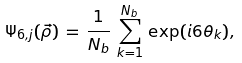Convert formula to latex. <formula><loc_0><loc_0><loc_500><loc_500>\Psi _ { 6 , j } ( \vec { \rho } ) \, = \, \frac { 1 } { N _ { b } } \, \sum _ { k = 1 } ^ { N _ { b } } \, \exp ( i 6 \theta _ { k } ) ,</formula> 